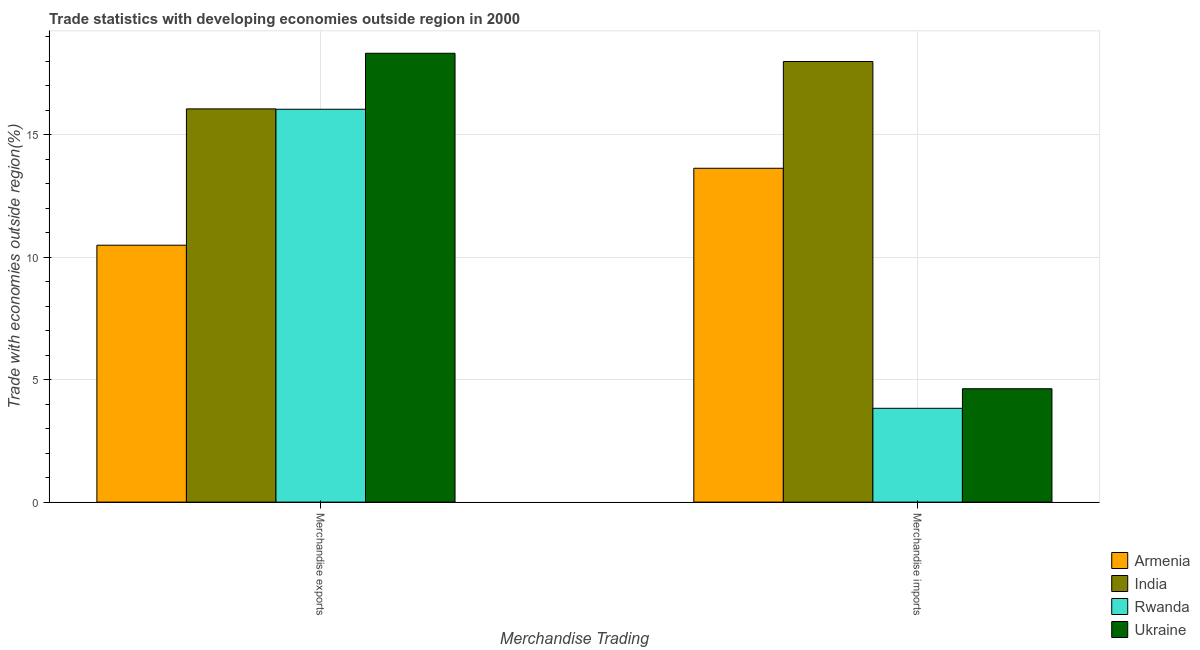How many different coloured bars are there?
Provide a short and direct response. 4. Are the number of bars on each tick of the X-axis equal?
Offer a terse response. Yes. How many bars are there on the 2nd tick from the left?
Keep it short and to the point. 4. How many bars are there on the 2nd tick from the right?
Give a very brief answer. 4. What is the merchandise imports in India?
Provide a short and direct response. 17.99. Across all countries, what is the maximum merchandise imports?
Your response must be concise. 17.99. Across all countries, what is the minimum merchandise exports?
Your response must be concise. 10.49. In which country was the merchandise exports maximum?
Ensure brevity in your answer.  Ukraine. In which country was the merchandise imports minimum?
Offer a terse response. Rwanda. What is the total merchandise imports in the graph?
Offer a very short reply. 40.07. What is the difference between the merchandise imports in India and that in Ukraine?
Offer a terse response. 13.36. What is the difference between the merchandise imports in Ukraine and the merchandise exports in Rwanda?
Keep it short and to the point. -11.41. What is the average merchandise exports per country?
Provide a short and direct response. 15.23. What is the difference between the merchandise imports and merchandise exports in Ukraine?
Keep it short and to the point. -13.69. In how many countries, is the merchandise imports greater than 15 %?
Your answer should be very brief. 1. What is the ratio of the merchandise exports in Rwanda to that in Ukraine?
Ensure brevity in your answer.  0.88. Is the merchandise imports in India less than that in Rwanda?
Provide a succinct answer. No. In how many countries, is the merchandise exports greater than the average merchandise exports taken over all countries?
Give a very brief answer. 3. What does the 3rd bar from the left in Merchandise imports represents?
Make the answer very short. Rwanda. What does the 2nd bar from the right in Merchandise imports represents?
Offer a terse response. Rwanda. How many bars are there?
Your answer should be compact. 8. Are all the bars in the graph horizontal?
Your answer should be compact. No. How many countries are there in the graph?
Offer a terse response. 4. How many legend labels are there?
Ensure brevity in your answer.  4. How are the legend labels stacked?
Your answer should be compact. Vertical. What is the title of the graph?
Keep it short and to the point. Trade statistics with developing economies outside region in 2000. Does "Other small states" appear as one of the legend labels in the graph?
Make the answer very short. No. What is the label or title of the X-axis?
Make the answer very short. Merchandise Trading. What is the label or title of the Y-axis?
Your response must be concise. Trade with economies outside region(%). What is the Trade with economies outside region(%) in Armenia in Merchandise exports?
Your response must be concise. 10.49. What is the Trade with economies outside region(%) of India in Merchandise exports?
Your response must be concise. 16.05. What is the Trade with economies outside region(%) of Rwanda in Merchandise exports?
Keep it short and to the point. 16.04. What is the Trade with economies outside region(%) of Ukraine in Merchandise exports?
Provide a succinct answer. 18.32. What is the Trade with economies outside region(%) of Armenia in Merchandise imports?
Provide a short and direct response. 13.63. What is the Trade with economies outside region(%) of India in Merchandise imports?
Make the answer very short. 17.99. What is the Trade with economies outside region(%) in Rwanda in Merchandise imports?
Ensure brevity in your answer.  3.83. What is the Trade with economies outside region(%) of Ukraine in Merchandise imports?
Ensure brevity in your answer.  4.63. Across all Merchandise Trading, what is the maximum Trade with economies outside region(%) of Armenia?
Keep it short and to the point. 13.63. Across all Merchandise Trading, what is the maximum Trade with economies outside region(%) of India?
Your response must be concise. 17.99. Across all Merchandise Trading, what is the maximum Trade with economies outside region(%) of Rwanda?
Offer a very short reply. 16.04. Across all Merchandise Trading, what is the maximum Trade with economies outside region(%) of Ukraine?
Keep it short and to the point. 18.32. Across all Merchandise Trading, what is the minimum Trade with economies outside region(%) of Armenia?
Your response must be concise. 10.49. Across all Merchandise Trading, what is the minimum Trade with economies outside region(%) in India?
Keep it short and to the point. 16.05. Across all Merchandise Trading, what is the minimum Trade with economies outside region(%) of Rwanda?
Provide a succinct answer. 3.83. Across all Merchandise Trading, what is the minimum Trade with economies outside region(%) of Ukraine?
Make the answer very short. 4.63. What is the total Trade with economies outside region(%) of Armenia in the graph?
Offer a terse response. 24.12. What is the total Trade with economies outside region(%) of India in the graph?
Your response must be concise. 34.04. What is the total Trade with economies outside region(%) in Rwanda in the graph?
Ensure brevity in your answer.  19.87. What is the total Trade with economies outside region(%) in Ukraine in the graph?
Offer a very short reply. 22.95. What is the difference between the Trade with economies outside region(%) of Armenia in Merchandise exports and that in Merchandise imports?
Offer a very short reply. -3.14. What is the difference between the Trade with economies outside region(%) in India in Merchandise exports and that in Merchandise imports?
Provide a short and direct response. -1.93. What is the difference between the Trade with economies outside region(%) in Rwanda in Merchandise exports and that in Merchandise imports?
Give a very brief answer. 12.21. What is the difference between the Trade with economies outside region(%) in Ukraine in Merchandise exports and that in Merchandise imports?
Offer a terse response. 13.69. What is the difference between the Trade with economies outside region(%) in Armenia in Merchandise exports and the Trade with economies outside region(%) in India in Merchandise imports?
Ensure brevity in your answer.  -7.5. What is the difference between the Trade with economies outside region(%) in Armenia in Merchandise exports and the Trade with economies outside region(%) in Rwanda in Merchandise imports?
Provide a short and direct response. 6.66. What is the difference between the Trade with economies outside region(%) in Armenia in Merchandise exports and the Trade with economies outside region(%) in Ukraine in Merchandise imports?
Keep it short and to the point. 5.86. What is the difference between the Trade with economies outside region(%) of India in Merchandise exports and the Trade with economies outside region(%) of Rwanda in Merchandise imports?
Ensure brevity in your answer.  12.22. What is the difference between the Trade with economies outside region(%) of India in Merchandise exports and the Trade with economies outside region(%) of Ukraine in Merchandise imports?
Your answer should be very brief. 11.42. What is the difference between the Trade with economies outside region(%) of Rwanda in Merchandise exports and the Trade with economies outside region(%) of Ukraine in Merchandise imports?
Provide a short and direct response. 11.41. What is the average Trade with economies outside region(%) of Armenia per Merchandise Trading?
Give a very brief answer. 12.06. What is the average Trade with economies outside region(%) of India per Merchandise Trading?
Give a very brief answer. 17.02. What is the average Trade with economies outside region(%) in Rwanda per Merchandise Trading?
Your answer should be compact. 9.93. What is the average Trade with economies outside region(%) of Ukraine per Merchandise Trading?
Give a very brief answer. 11.48. What is the difference between the Trade with economies outside region(%) of Armenia and Trade with economies outside region(%) of India in Merchandise exports?
Your answer should be very brief. -5.56. What is the difference between the Trade with economies outside region(%) in Armenia and Trade with economies outside region(%) in Rwanda in Merchandise exports?
Offer a very short reply. -5.55. What is the difference between the Trade with economies outside region(%) of Armenia and Trade with economies outside region(%) of Ukraine in Merchandise exports?
Offer a very short reply. -7.84. What is the difference between the Trade with economies outside region(%) in India and Trade with economies outside region(%) in Rwanda in Merchandise exports?
Make the answer very short. 0.02. What is the difference between the Trade with economies outside region(%) in India and Trade with economies outside region(%) in Ukraine in Merchandise exports?
Offer a very short reply. -2.27. What is the difference between the Trade with economies outside region(%) in Rwanda and Trade with economies outside region(%) in Ukraine in Merchandise exports?
Your answer should be very brief. -2.29. What is the difference between the Trade with economies outside region(%) of Armenia and Trade with economies outside region(%) of India in Merchandise imports?
Ensure brevity in your answer.  -4.36. What is the difference between the Trade with economies outside region(%) of Armenia and Trade with economies outside region(%) of Rwanda in Merchandise imports?
Offer a terse response. 9.8. What is the difference between the Trade with economies outside region(%) of Armenia and Trade with economies outside region(%) of Ukraine in Merchandise imports?
Offer a terse response. 9. What is the difference between the Trade with economies outside region(%) in India and Trade with economies outside region(%) in Rwanda in Merchandise imports?
Offer a very short reply. 14.16. What is the difference between the Trade with economies outside region(%) in India and Trade with economies outside region(%) in Ukraine in Merchandise imports?
Keep it short and to the point. 13.36. What is the difference between the Trade with economies outside region(%) in Rwanda and Trade with economies outside region(%) in Ukraine in Merchandise imports?
Make the answer very short. -0.8. What is the ratio of the Trade with economies outside region(%) of Armenia in Merchandise exports to that in Merchandise imports?
Give a very brief answer. 0.77. What is the ratio of the Trade with economies outside region(%) of India in Merchandise exports to that in Merchandise imports?
Make the answer very short. 0.89. What is the ratio of the Trade with economies outside region(%) of Rwanda in Merchandise exports to that in Merchandise imports?
Offer a terse response. 4.19. What is the ratio of the Trade with economies outside region(%) in Ukraine in Merchandise exports to that in Merchandise imports?
Your answer should be very brief. 3.96. What is the difference between the highest and the second highest Trade with economies outside region(%) of Armenia?
Provide a succinct answer. 3.14. What is the difference between the highest and the second highest Trade with economies outside region(%) in India?
Keep it short and to the point. 1.93. What is the difference between the highest and the second highest Trade with economies outside region(%) of Rwanda?
Give a very brief answer. 12.21. What is the difference between the highest and the second highest Trade with economies outside region(%) in Ukraine?
Make the answer very short. 13.69. What is the difference between the highest and the lowest Trade with economies outside region(%) of Armenia?
Provide a succinct answer. 3.14. What is the difference between the highest and the lowest Trade with economies outside region(%) of India?
Provide a short and direct response. 1.93. What is the difference between the highest and the lowest Trade with economies outside region(%) in Rwanda?
Provide a short and direct response. 12.21. What is the difference between the highest and the lowest Trade with economies outside region(%) in Ukraine?
Make the answer very short. 13.69. 